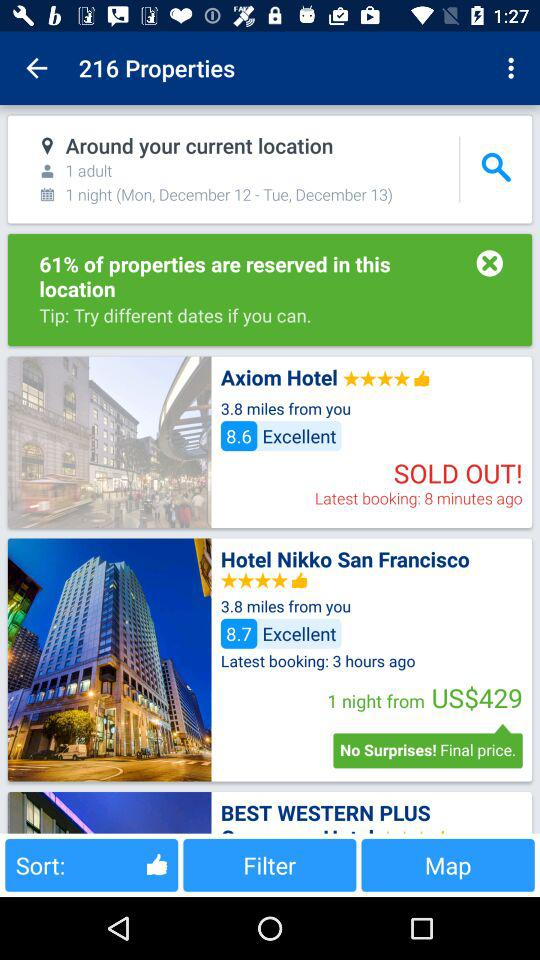What is the review of the Axiom Hotel? The review is "Excellent". 